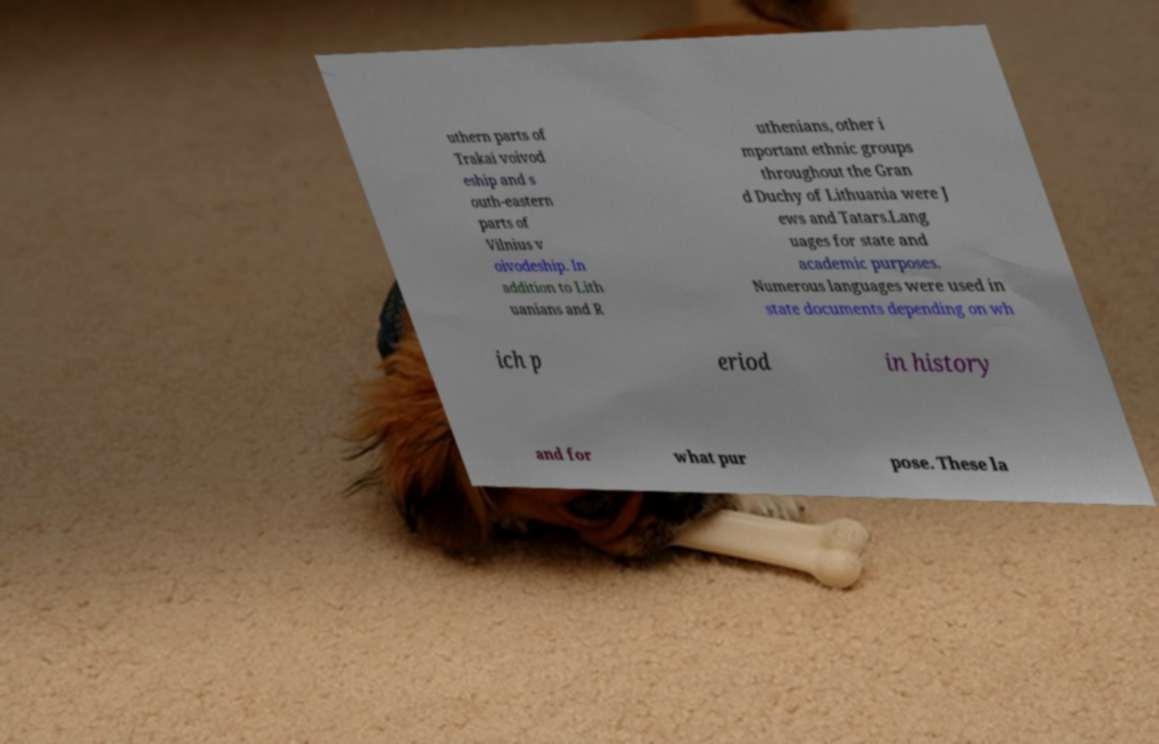Could you extract and type out the text from this image? uthern parts of Trakai voivod eship and s outh-eastern parts of Vilnius v oivodeship. In addition to Lith uanians and R uthenians, other i mportant ethnic groups throughout the Gran d Duchy of Lithuania were J ews and Tatars.Lang uages for state and academic purposes. Numerous languages were used in state documents depending on wh ich p eriod in history and for what pur pose. These la 